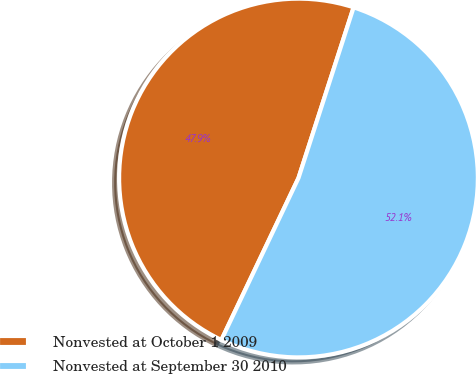<chart> <loc_0><loc_0><loc_500><loc_500><pie_chart><fcel>Nonvested at October 1 2009<fcel>Nonvested at September 30 2010<nl><fcel>47.9%<fcel>52.1%<nl></chart> 